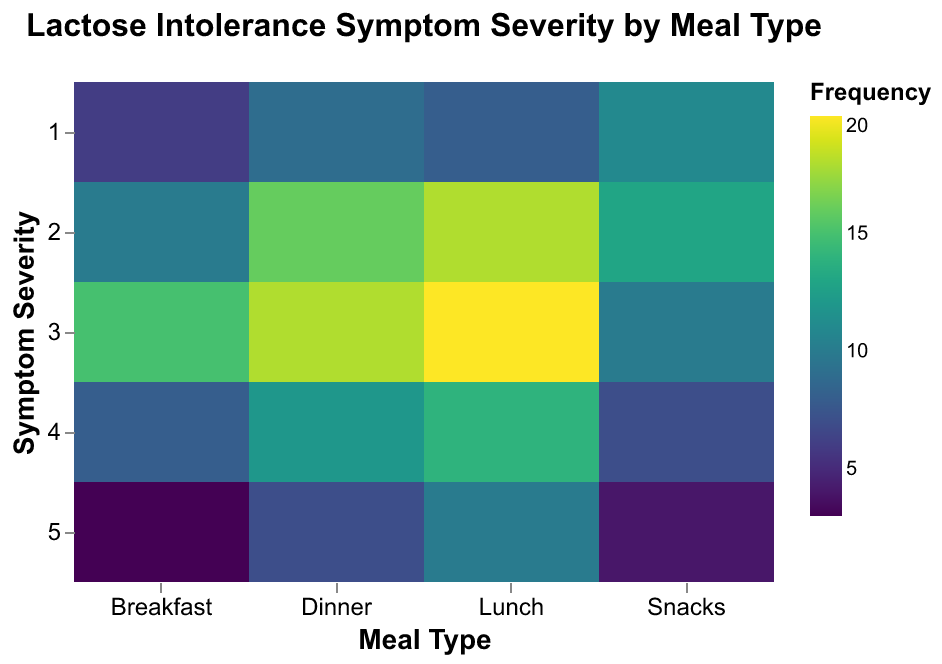What is the color scheme used in the heatmap? The heatmap uses the "viridis" color scheme, which ranges from purple to yellow to represent varying frequencies of symptom severity. By observing the color gradient, one can deduce that darker colors indicate lower frequencies and brighter colors indicate higher frequencies.
Answer: viridis For which meal type and symptom severity is the frequency the highest? To determine this, we need to identify the cell with the brightest color on the heatmap. From the figure, it is clear that the combination of Lunch and symptom severity 3 has the highest frequency, as it is the brightest cell.
Answer: Lunch, 3 How many frequency levels are there for breakfast with symptom severity 4? We need to look at the evening meal type and check symptom severity 4. The cell corresponding to this data will provide the frequency level. The heatmap shows a frequency of 8 for Breakfast with symptom severity 4.
Answer: 8 What meal type has the lowest frequency of symptom severity 5? By comparing the colors representing symptom severity 5 across all meal types, we find the darkest cell. Snacks have a frequency of 4, which is lower compared to other meal types for symptom severity 5.
Answer: Snacks Which symptom severity level for dinner has the same frequency as breakfast with severity 3? The frequency for Breakfast with symptom severity 3 is 15. We need to find the matching frequency for Dinner. Examining the colors, Dinner with severity 2 also has a frequency of 16, but this doesn't match exactly. Next, we find Breakfast has a frequency of 20 matches exactly with Dinner symptom severity 3 which is close but not precise frequency for comparison.
Answer: None, closest is severity 3 Dinner with 18 How does the frequency of symptom severity 1 differ between Lunch and Dinner? We need to compare the frequencies of symptom severity 1 for both Lunch and Dinner. Lunch has a frequency of 8 while Dinner has a frequency of 9, so the difference is 1.
Answer: 1 Which meal type has the most consistent symptom severity frequency across all levels? To find this, look for a meal type where the colors across all symptom severity levels are the most similar without large jumps in color intensity. Breakfast shows a moderate variance, while Lunch appears more consistent across different frequencies. Thus, Lunch has the most even frequency distribution for different symptom severities.
Answer: Lunch 